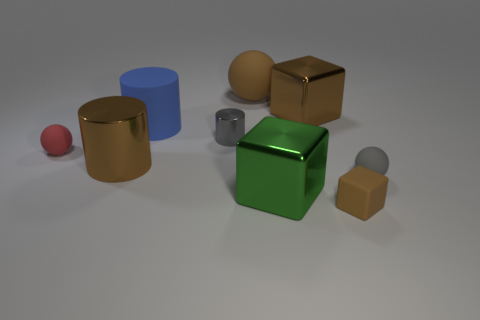What material is the small block that is the same color as the large rubber ball?
Make the answer very short. Rubber. What number of big matte balls are the same color as the small shiny object?
Offer a terse response. 0. Is the number of green metal cubes behind the big blue thing the same as the number of big metallic cylinders?
Give a very brief answer. No. The tiny cylinder has what color?
Your answer should be very brief. Gray. There is a brown object that is made of the same material as the big brown block; what is its size?
Your answer should be very brief. Large. There is a large cylinder that is made of the same material as the large green thing; what color is it?
Offer a terse response. Brown. Is there a metallic cylinder of the same size as the red matte object?
Give a very brief answer. Yes. What is the material of the large blue object that is the same shape as the gray metallic thing?
Provide a short and direct response. Rubber. There is a brown rubber thing that is the same size as the brown metal cylinder; what shape is it?
Provide a short and direct response. Sphere. Is there a large brown thing of the same shape as the gray metallic thing?
Your response must be concise. Yes. 